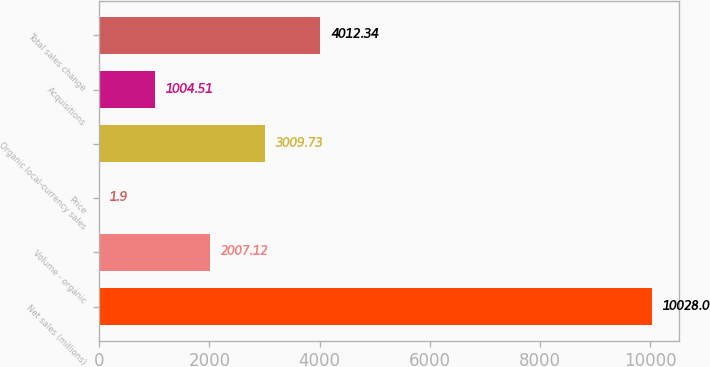<chart> <loc_0><loc_0><loc_500><loc_500><bar_chart><fcel>Net sales (millions)<fcel>Volume - organic<fcel>Price<fcel>Organic local-currency sales<fcel>Acquisitions<fcel>Total sales change<nl><fcel>10028<fcel>2007.12<fcel>1.9<fcel>3009.73<fcel>1004.51<fcel>4012.34<nl></chart> 